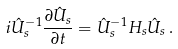Convert formula to latex. <formula><loc_0><loc_0><loc_500><loc_500>i \hat { U } _ { s } ^ { - 1 } \frac { \partial \hat { U } _ { s } } { \partial t } = \hat { U } _ { s } ^ { - 1 } H _ { s } \hat { U } _ { s } \, .</formula> 